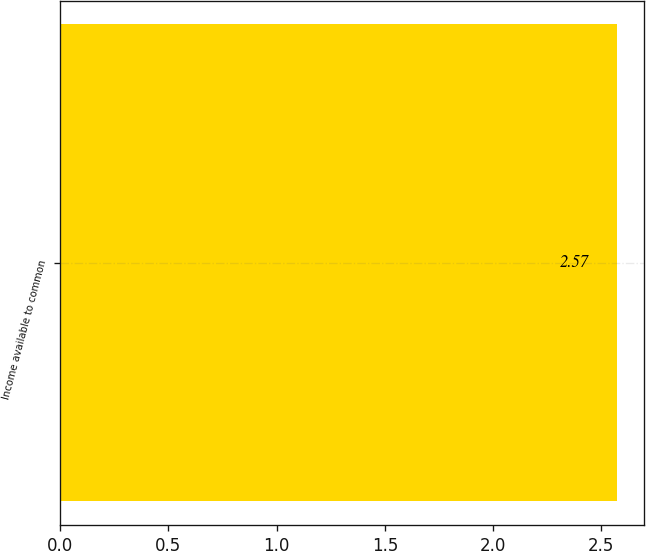Convert chart to OTSL. <chart><loc_0><loc_0><loc_500><loc_500><bar_chart><fcel>Income available to common<nl><fcel>2.57<nl></chart> 